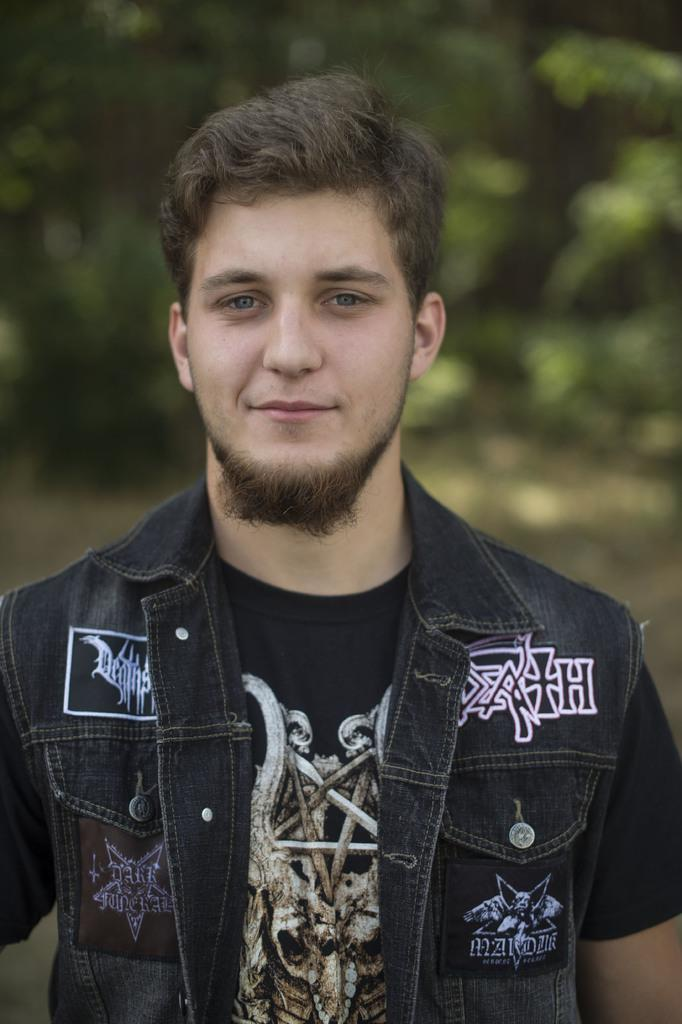What is the main subject in the foreground of the image? There is a person in the foreground of the image. Can you describe the person's appearance? The person has black hair. What can be observed about the background of the image? The background of the image is blurred. What type of joke is the person attempting to tell in the image? There is no indication in the image that the person is attempting to tell a joke, so it cannot be determined from the picture. 